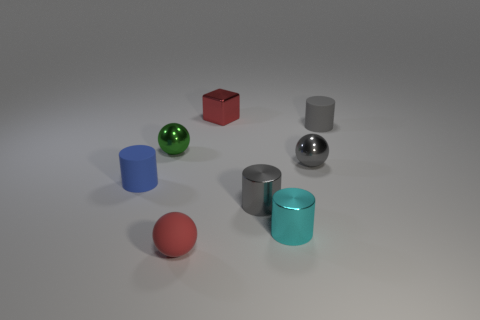Add 1 tiny cyan metallic things. How many objects exist? 9 Subtract all balls. How many objects are left? 5 Subtract all tiny gray matte cylinders. Subtract all red metal cubes. How many objects are left? 6 Add 4 green metal spheres. How many green metal spheres are left? 5 Add 3 tiny green metallic objects. How many tiny green metallic objects exist? 4 Subtract 0 red cylinders. How many objects are left? 8 